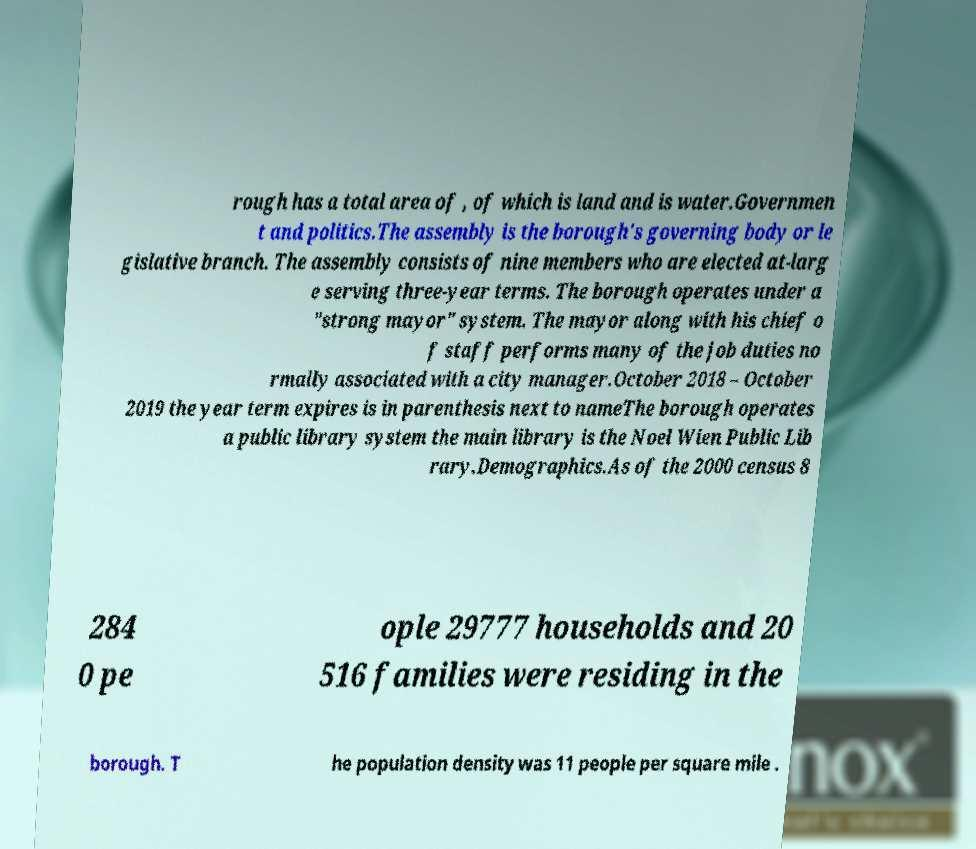Please read and relay the text visible in this image. What does it say? rough has a total area of , of which is land and is water.Governmen t and politics.The assembly is the borough's governing body or le gislative branch. The assembly consists of nine members who are elected at-larg e serving three-year terms. The borough operates under a "strong mayor" system. The mayor along with his chief o f staff performs many of the job duties no rmally associated with a city manager.October 2018 – October 2019 the year term expires is in parenthesis next to nameThe borough operates a public library system the main library is the Noel Wien Public Lib rary.Demographics.As of the 2000 census 8 284 0 pe ople 29777 households and 20 516 families were residing in the borough. T he population density was 11 people per square mile . 